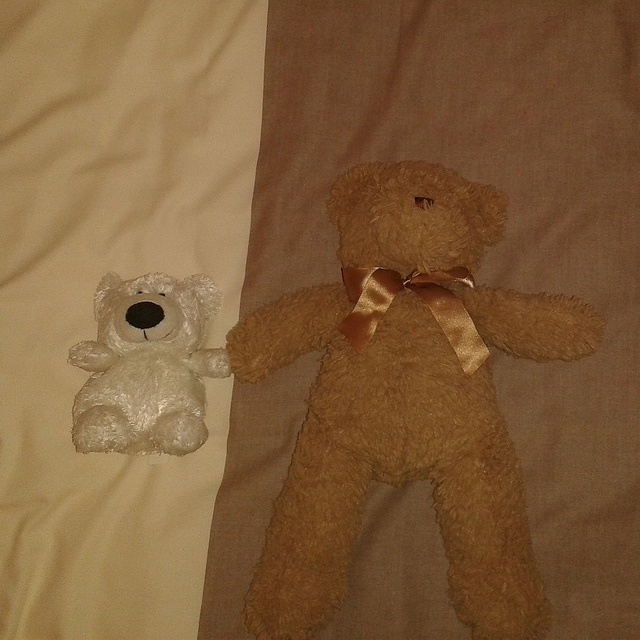Describe the objects in this image and their specific colors. I can see teddy bear in olive, maroon, and brown tones and teddy bear in olive, tan, and black tones in this image. 